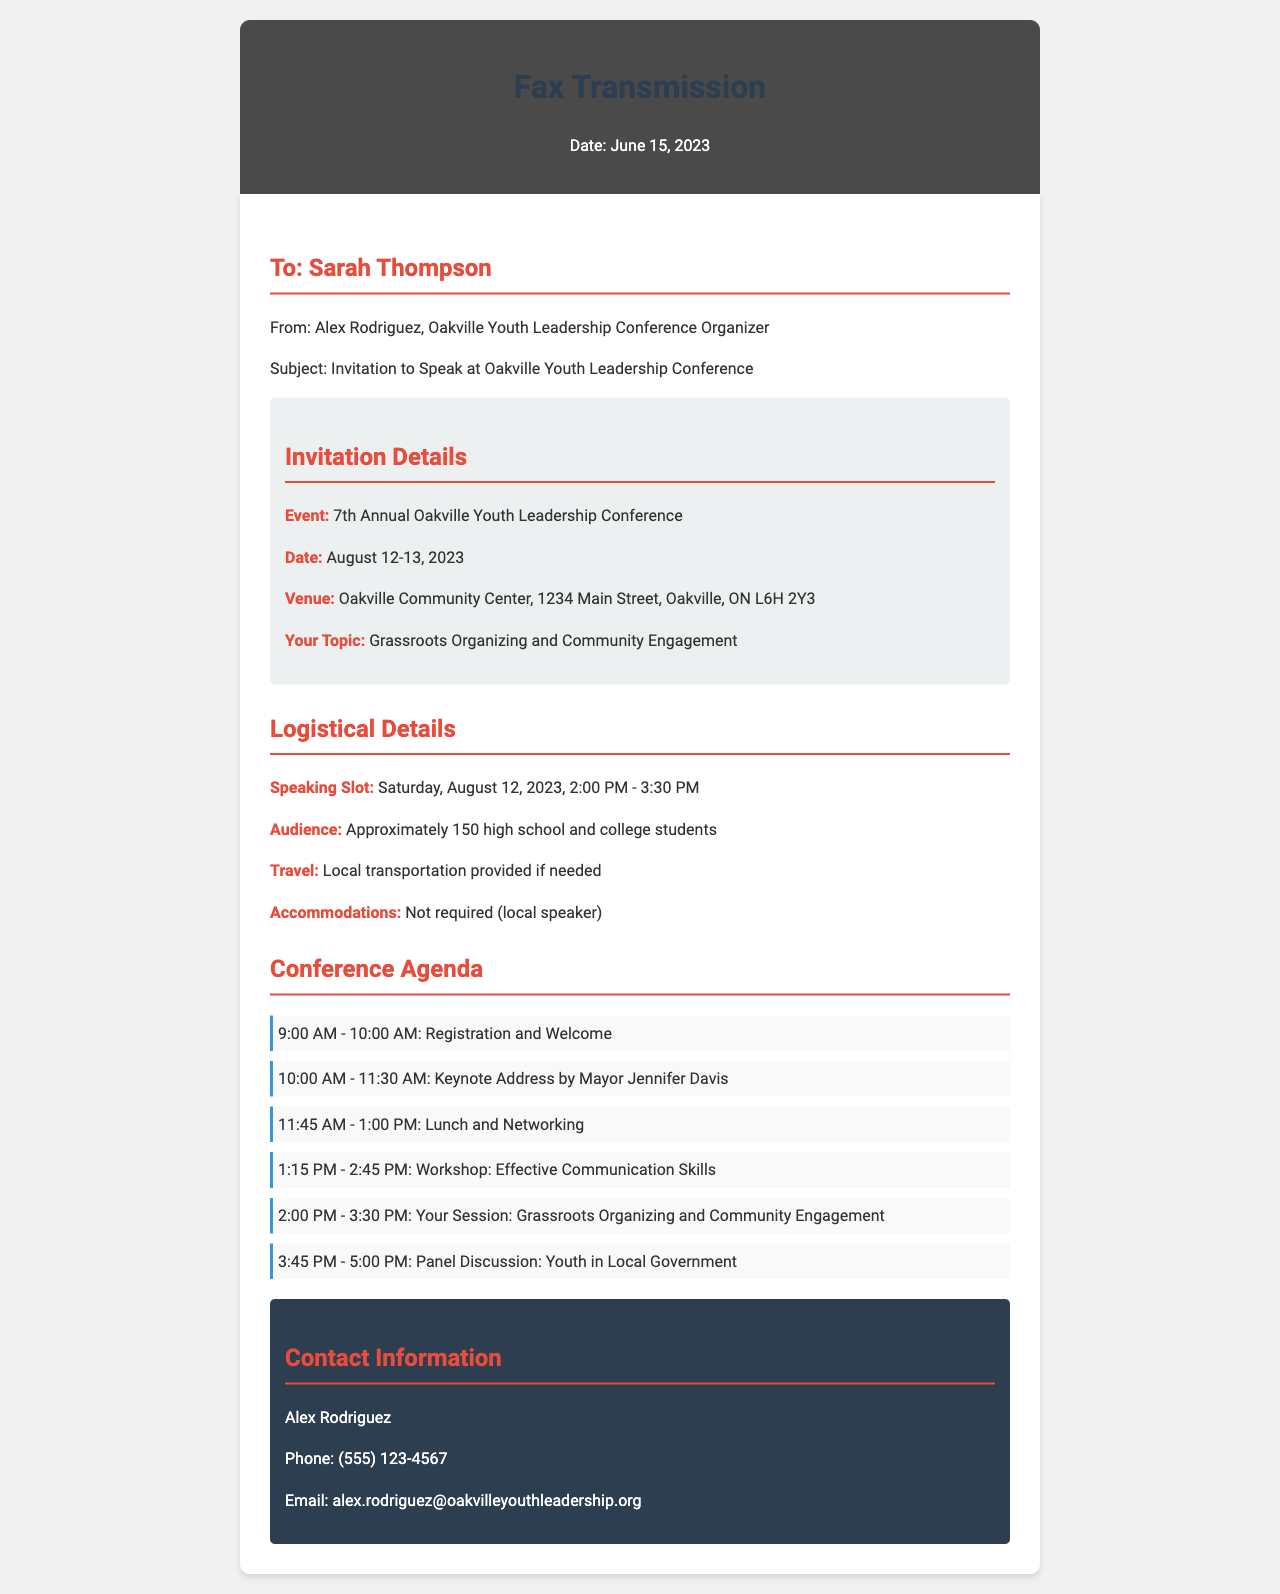What is the name of the event? The name of the event is specified in the invitation details section, which is "7th Annual Oakville Youth Leadership Conference."
Answer: 7th Annual Oakville Youth Leadership Conference What are the conference dates? The conference dates are provided in the invitation details section, which lists the dates as August 12-13, 2023.
Answer: August 12-13, 2023 Who is the keynote speaker? The keynote speaker is mentioned in the agenda section as Mayor Jennifer Davis, delivering the address from 10:00 AM to 11:30 AM.
Answer: Mayor Jennifer Davis What time is the speaking slot scheduled? The speaking slot timing is mentioned under logistical details as 2:00 PM - 3:30 PM on August 12, 2023.
Answer: 2:00 PM - 3:30 PM How many students are expected in the audience? The number of expected audience members is indicated in the logistical details, totaling approximately 150 students.
Answer: Approximately 150 What topic will the invitee speak on? The topic the invitee is expected to speak on is specified in the invitation details, which is "Grassroots Organizing and Community Engagement."
Answer: Grassroots Organizing and Community Engagement What local accommodations are provided for speakers? The logistical details mention that accommodations are not required for local speakers, indicating no accommodations provided.
Answer: Not required What is the contact person's email address? The contact person's email is listed in the contact information section as alex.rodriguez@oakvilleyouthleadership.org.
Answer: alex.rodriguez@oakvilleyouthleadership.org 